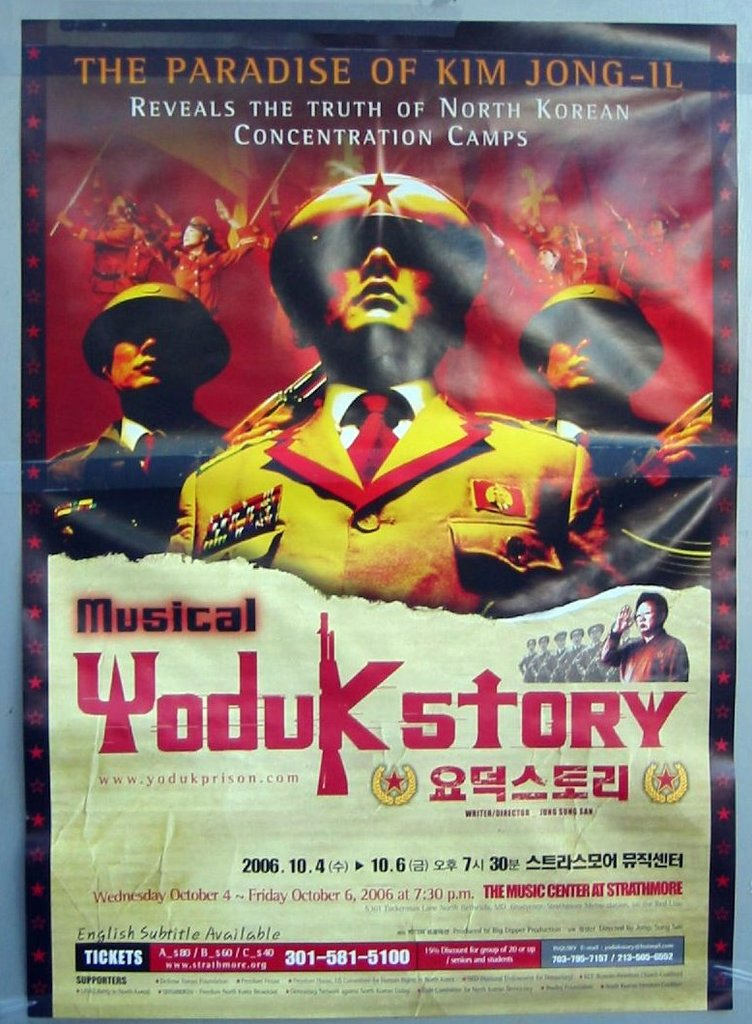Can you tell me more about the significance of the imagery used in the Yoduk Story poster? The imagery in the 'Yoduk Story' poster employs bold and striking visuals, with military figures and fire elements that symbolize the oppressive regime and the intense struggle of the individuals in North Korean camps. The colors, red and gold, emphasize urgency and drama, aligning with the musical's serious and impactful narrative. 